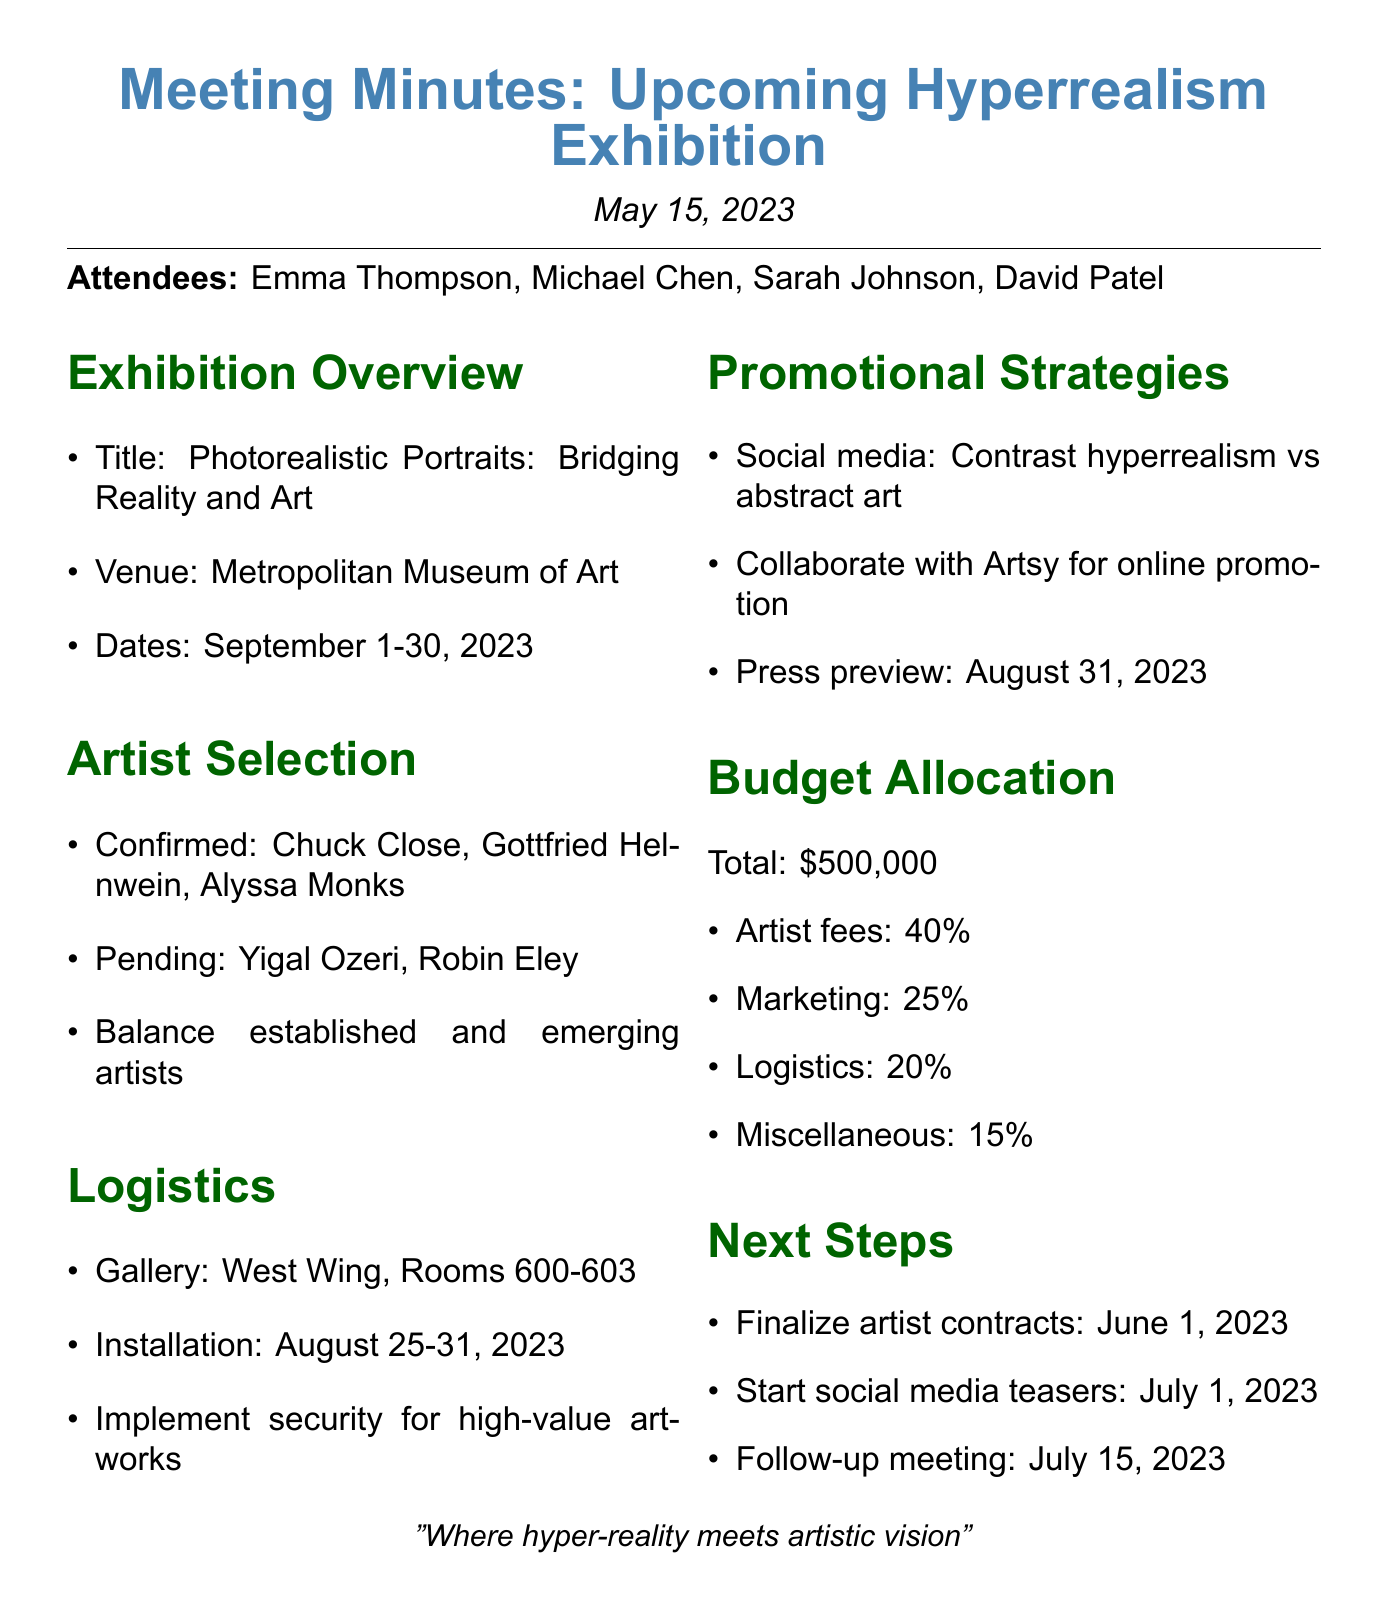What are the exhibition dates? The exhibition dates are specified as September 1-30, 2023.
Answer: September 1-30, 2023 Who are the confirmed artists? The document lists Chuck Close, Gottfried Helnwein, and Alyssa Monks as confirmed artists.
Answer: Chuck Close, Gottfried Helnwein, Alyssa Monks What is the total budget for the exhibition? The total budget mentioned in the document is $500,000.
Answer: $500,000 When is the press preview event scheduled? The document states the press preview event is scheduled for August 31, 2023.
Answer: August 31, 2023 What is the gallery space allocated for the exhibition? The gallery space mentioned is the West Wing, Rooms 600-603.
Answer: West Wing, Rooms 600-603 How much of the budget is allocated for marketing and promotion? The document specifies that 25% of the total budget is allocated for marketing and promotion.
Answer: 25% What is the significance of balancing established and emerging artists? This indicates the intention to create a diverse representation of talent in the exhibition.
Answer: A diverse representation of talent When is the follow-up meeting scheduled? The next follow-up meeting is set for July 15, 2023, according to the document.
Answer: July 15, 2023 